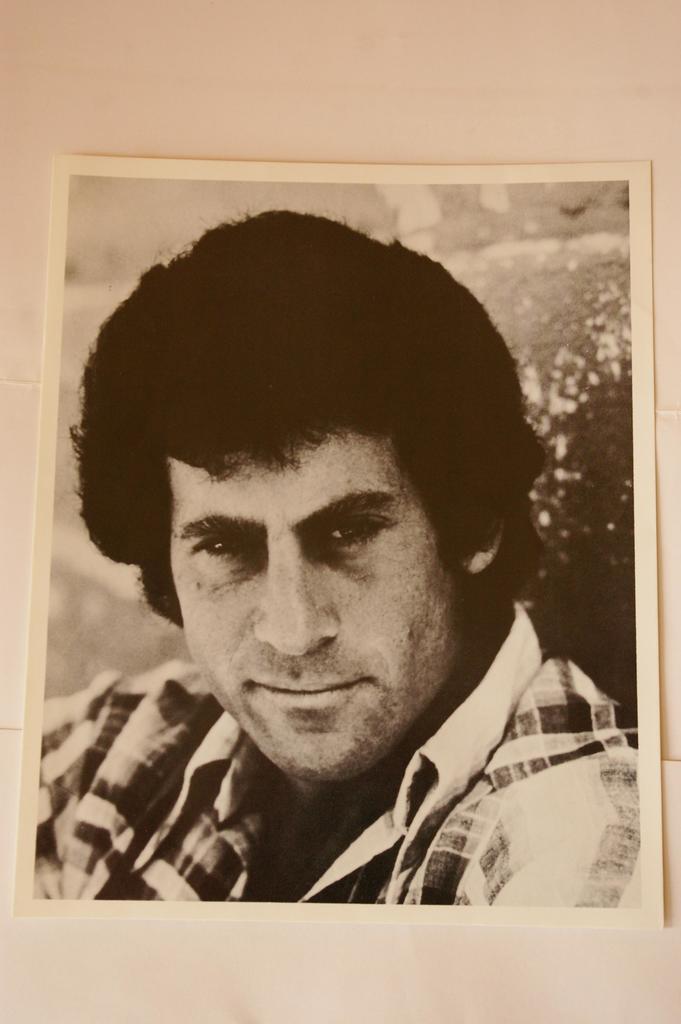Can you describe this image briefly? In this image I can see a photo of person on the table. 